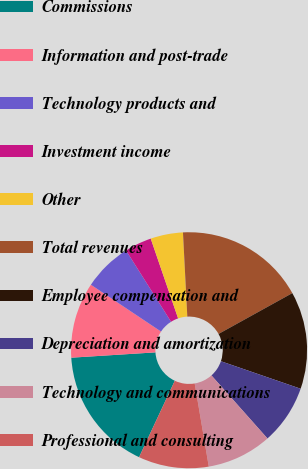<chart> <loc_0><loc_0><loc_500><loc_500><pie_chart><fcel>Commissions<fcel>Information and post-trade<fcel>Technology products and<fcel>Investment income<fcel>Other<fcel>Total revenues<fcel>Employee compensation and<fcel>Depreciation and amortization<fcel>Technology and communications<fcel>Professional and consulting<nl><fcel>17.04%<fcel>10.37%<fcel>6.67%<fcel>3.7%<fcel>4.44%<fcel>17.78%<fcel>13.33%<fcel>8.15%<fcel>8.89%<fcel>9.63%<nl></chart> 